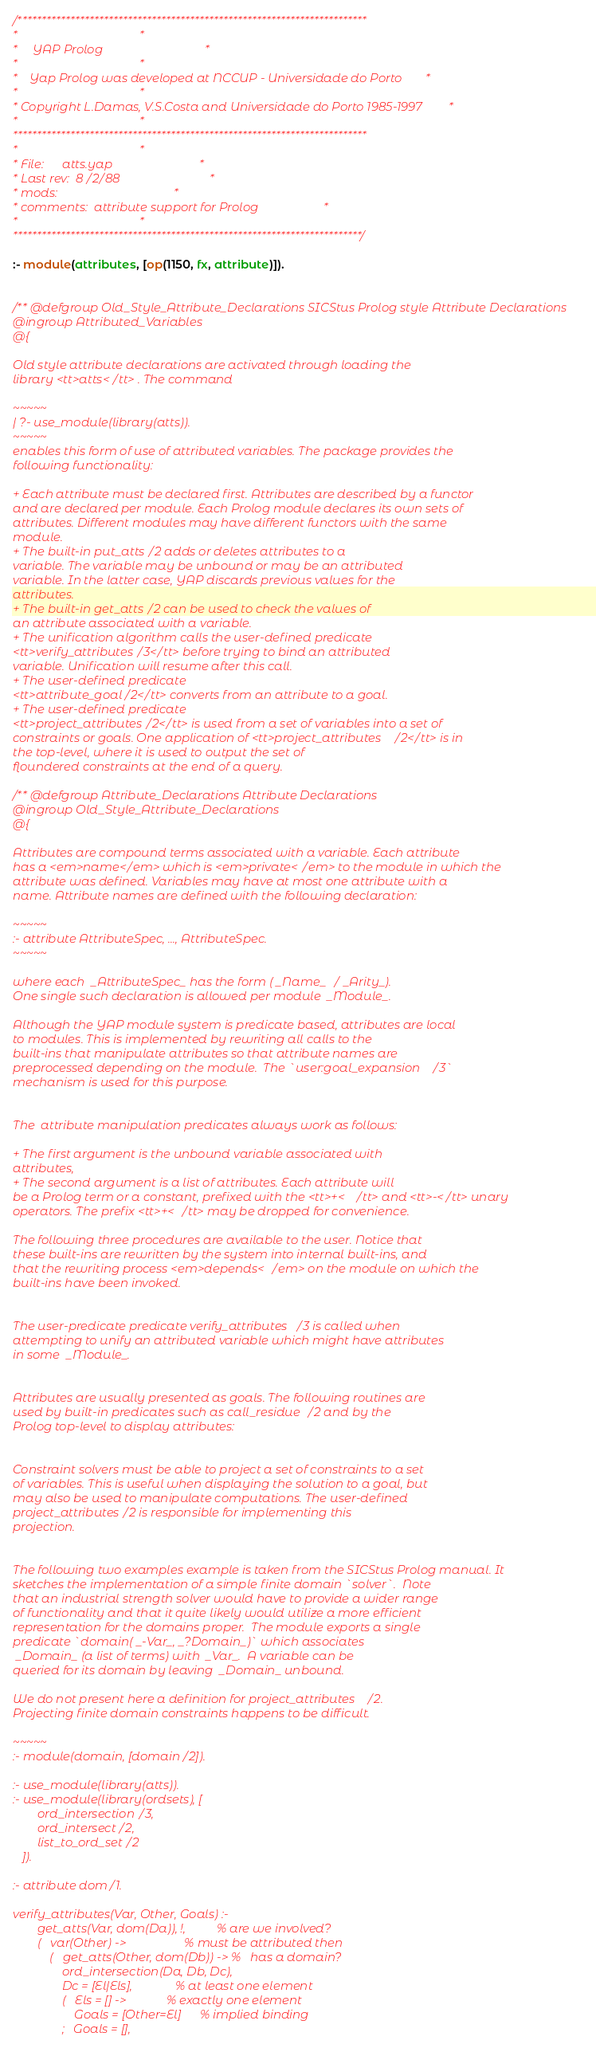<code> <loc_0><loc_0><loc_500><loc_500><_Prolog_>/*************************************************************************
*									 *
*	 YAP Prolog 							 *
*									 *
*	Yap Prolog was developed at NCCUP - Universidade do Porto	 *
*									 *
* Copyright L.Damas, V.S.Costa and Universidade do Porto 1985-1997	 *
*									 *
**************************************************************************
*									 *
* File:		atts.yap						 *
* Last rev:	8/2/88							 *
* mods:									 *
* comments:	attribute support for Prolog				 *
*									 *
*************************************************************************/

:- module(attributes, [op(1150, fx, attribute)]).


/** @defgroup Old_Style_Attribute_Declarations SICStus Prolog style Attribute Declarations
@ingroup Attributed_Variables
@{

Old style attribute declarations are activated through loading the
library <tt>atts</tt> . The command

~~~~~
| ?- use_module(library(atts)).
~~~~~
enables this form of use of attributed variables. The package provides the
following functionality:

+ Each attribute must be declared first. Attributes are described by a functor
and are declared per module. Each Prolog module declares its own sets of
attributes. Different modules may have different functors with the same
module.
+ The built-in put_atts/2 adds or deletes attributes to a
variable. The variable may be unbound or may be an attributed
variable. In the latter case, YAP discards previous values for the
attributes.
+ The built-in get_atts/2 can be used to check the values of
an attribute associated with a variable.
+ The unification algorithm calls the user-defined predicate
<tt>verify_attributes/3</tt> before trying to bind an attributed
variable. Unification will resume after this call.
+ The user-defined predicate
<tt>attribute_goal/2</tt> converts from an attribute to a goal.
+ The user-defined predicate
<tt>project_attributes/2</tt> is used from a set of variables into a set of
constraints or goals. One application of <tt>project_attributes/2</tt> is in
the top-level, where it is used to output the set of
floundered constraints at the end of a query.

/** @defgroup Attribute_Declarations Attribute Declarations
@ingroup Old_Style_Attribute_Declarations
@{

Attributes are compound terms associated with a variable. Each attribute
has a <em>name</em> which is <em>private</em> to the module in which the
attribute was defined. Variables may have at most one attribute with a
name. Attribute names are defined with the following declaration:

~~~~~
:- attribute AttributeSpec, ..., AttributeSpec.
~~~~~

where each  _AttributeSpec_ has the form ( _Name_/ _Arity_).
One single such declaration is allowed per module  _Module_.

Although the YAP module system is predicate based, attributes are local
to modules. This is implemented by rewriting all calls to the
built-ins that manipulate attributes so that attribute names are
preprocessed depending on the module.  The `user:goal_expansion/3`
mechanism is used for this purpose.


The  attribute manipulation predicates always work as follows:

+ The first argument is the unbound variable associated with
attributes,
+ The second argument is a list of attributes. Each attribute will
be a Prolog term or a constant, prefixed with the <tt>+</tt> and <tt>-</tt> unary
operators. The prefix <tt>+</tt> may be dropped for convenience.

The following three procedures are available to the user. Notice that
these built-ins are rewritten by the system into internal built-ins, and
that the rewriting process <em>depends</em> on the module on which the
built-ins have been invoked.

 
The user-predicate predicate verify_attributes/3 is called when
attempting to unify an attributed variable which might have attributes
in some  _Module_.

 
Attributes are usually presented as goals. The following routines are
used by built-in predicates such as call_residue/2 and by the
Prolog top-level to display attributes:

 
Constraint solvers must be able to project a set of constraints to a set
of variables. This is useful when displaying the solution to a goal, but
may also be used to manipulate computations. The user-defined
project_attributes/2 is responsible for implementing this
projection.


The following two examples example is taken from the SICStus Prolog manual. It
sketches the implementation of a simple finite domain `solver`.  Note
that an industrial strength solver would have to provide a wider range
of functionality and that it quite likely would utilize a more efficient
representation for the domains proper.  The module exports a single
predicate `domain( _-Var_, _?Domain_)` which associates
 _Domain_ (a list of terms) with  _Var_.  A variable can be
queried for its domain by leaving  _Domain_ unbound.

We do not present here a definition for project_attributes/2.
Projecting finite domain constraints happens to be difficult.

~~~~~
:- module(domain, [domain/2]).

:- use_module(library(atts)).
:- use_module(library(ordsets), [
        ord_intersection/3,
        ord_intersect/2,
        list_to_ord_set/2
   ]).

:- attribute dom/1.

verify_attributes(Var, Other, Goals) :-
        get_atts(Var, dom(Da)), !,          % are we involved?
        (   var(Other) ->                   % must be attributed then
            (   get_atts(Other, dom(Db)) -> %   has a domain?
                ord_intersection(Da, Db, Dc),
                Dc = [El|Els],              % at least one element
                (   Els = [] ->             % exactly one element
                    Goals = [Other=El]      % implied binding
                ;   Goals = [],</code> 